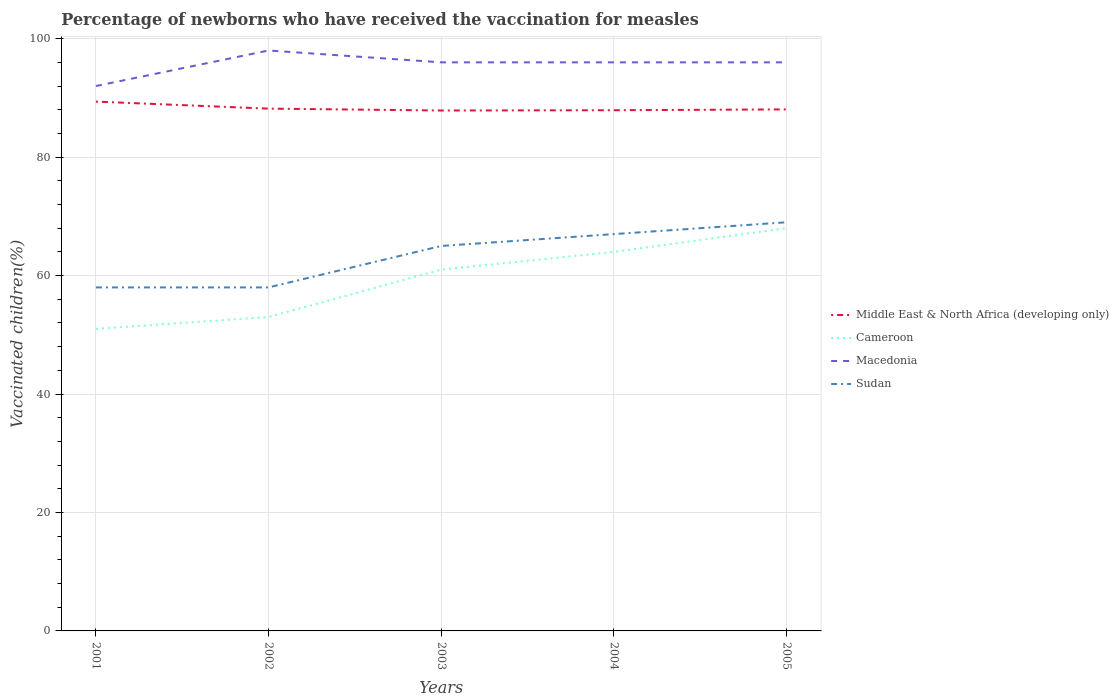How many different coloured lines are there?
Your answer should be very brief. 4. Is the number of lines equal to the number of legend labels?
Offer a very short reply. Yes. Across all years, what is the maximum percentage of vaccinated children in Middle East & North Africa (developing only)?
Provide a succinct answer. 87.87. In which year was the percentage of vaccinated children in Sudan maximum?
Offer a very short reply. 2001. How many lines are there?
Your response must be concise. 4. How many years are there in the graph?
Give a very brief answer. 5. Are the values on the major ticks of Y-axis written in scientific E-notation?
Keep it short and to the point. No. Does the graph contain any zero values?
Make the answer very short. No. What is the title of the graph?
Your answer should be very brief. Percentage of newborns who have received the vaccination for measles. What is the label or title of the Y-axis?
Your answer should be compact. Vaccinated children(%). What is the Vaccinated children(%) of Middle East & North Africa (developing only) in 2001?
Keep it short and to the point. 89.37. What is the Vaccinated children(%) in Macedonia in 2001?
Offer a very short reply. 92. What is the Vaccinated children(%) of Middle East & North Africa (developing only) in 2002?
Offer a very short reply. 88.19. What is the Vaccinated children(%) in Macedonia in 2002?
Your response must be concise. 98. What is the Vaccinated children(%) of Sudan in 2002?
Offer a terse response. 58. What is the Vaccinated children(%) of Middle East & North Africa (developing only) in 2003?
Give a very brief answer. 87.87. What is the Vaccinated children(%) in Cameroon in 2003?
Offer a terse response. 61. What is the Vaccinated children(%) of Macedonia in 2003?
Offer a terse response. 96. What is the Vaccinated children(%) in Sudan in 2003?
Offer a very short reply. 65. What is the Vaccinated children(%) of Middle East & North Africa (developing only) in 2004?
Ensure brevity in your answer.  87.91. What is the Vaccinated children(%) of Cameroon in 2004?
Keep it short and to the point. 64. What is the Vaccinated children(%) of Macedonia in 2004?
Provide a succinct answer. 96. What is the Vaccinated children(%) of Middle East & North Africa (developing only) in 2005?
Your response must be concise. 88.05. What is the Vaccinated children(%) in Macedonia in 2005?
Your answer should be very brief. 96. Across all years, what is the maximum Vaccinated children(%) of Middle East & North Africa (developing only)?
Provide a short and direct response. 89.37. Across all years, what is the maximum Vaccinated children(%) in Sudan?
Offer a very short reply. 69. Across all years, what is the minimum Vaccinated children(%) in Middle East & North Africa (developing only)?
Give a very brief answer. 87.87. Across all years, what is the minimum Vaccinated children(%) in Macedonia?
Ensure brevity in your answer.  92. What is the total Vaccinated children(%) in Middle East & North Africa (developing only) in the graph?
Give a very brief answer. 441.39. What is the total Vaccinated children(%) in Cameroon in the graph?
Ensure brevity in your answer.  297. What is the total Vaccinated children(%) in Macedonia in the graph?
Provide a short and direct response. 478. What is the total Vaccinated children(%) in Sudan in the graph?
Give a very brief answer. 317. What is the difference between the Vaccinated children(%) of Middle East & North Africa (developing only) in 2001 and that in 2002?
Offer a very short reply. 1.19. What is the difference between the Vaccinated children(%) in Cameroon in 2001 and that in 2002?
Your answer should be very brief. -2. What is the difference between the Vaccinated children(%) of Sudan in 2001 and that in 2002?
Offer a terse response. 0. What is the difference between the Vaccinated children(%) of Middle East & North Africa (developing only) in 2001 and that in 2003?
Give a very brief answer. 1.51. What is the difference between the Vaccinated children(%) of Sudan in 2001 and that in 2003?
Provide a short and direct response. -7. What is the difference between the Vaccinated children(%) in Middle East & North Africa (developing only) in 2001 and that in 2004?
Give a very brief answer. 1.46. What is the difference between the Vaccinated children(%) in Cameroon in 2001 and that in 2004?
Offer a terse response. -13. What is the difference between the Vaccinated children(%) in Macedonia in 2001 and that in 2004?
Offer a very short reply. -4. What is the difference between the Vaccinated children(%) in Sudan in 2001 and that in 2004?
Your response must be concise. -9. What is the difference between the Vaccinated children(%) in Middle East & North Africa (developing only) in 2001 and that in 2005?
Provide a short and direct response. 1.32. What is the difference between the Vaccinated children(%) of Cameroon in 2001 and that in 2005?
Your answer should be compact. -17. What is the difference between the Vaccinated children(%) of Macedonia in 2001 and that in 2005?
Offer a very short reply. -4. What is the difference between the Vaccinated children(%) in Sudan in 2001 and that in 2005?
Your response must be concise. -11. What is the difference between the Vaccinated children(%) of Middle East & North Africa (developing only) in 2002 and that in 2003?
Ensure brevity in your answer.  0.32. What is the difference between the Vaccinated children(%) in Macedonia in 2002 and that in 2003?
Your answer should be very brief. 2. What is the difference between the Vaccinated children(%) in Middle East & North Africa (developing only) in 2002 and that in 2004?
Provide a short and direct response. 0.27. What is the difference between the Vaccinated children(%) of Cameroon in 2002 and that in 2004?
Your answer should be very brief. -11. What is the difference between the Vaccinated children(%) in Macedonia in 2002 and that in 2004?
Offer a terse response. 2. What is the difference between the Vaccinated children(%) of Middle East & North Africa (developing only) in 2002 and that in 2005?
Your answer should be compact. 0.13. What is the difference between the Vaccinated children(%) of Sudan in 2002 and that in 2005?
Offer a very short reply. -11. What is the difference between the Vaccinated children(%) in Middle East & North Africa (developing only) in 2003 and that in 2004?
Offer a terse response. -0.05. What is the difference between the Vaccinated children(%) in Macedonia in 2003 and that in 2004?
Your answer should be compact. 0. What is the difference between the Vaccinated children(%) in Sudan in 2003 and that in 2004?
Offer a terse response. -2. What is the difference between the Vaccinated children(%) in Middle East & North Africa (developing only) in 2003 and that in 2005?
Your answer should be compact. -0.19. What is the difference between the Vaccinated children(%) of Cameroon in 2003 and that in 2005?
Your answer should be very brief. -7. What is the difference between the Vaccinated children(%) in Macedonia in 2003 and that in 2005?
Your response must be concise. 0. What is the difference between the Vaccinated children(%) of Middle East & North Africa (developing only) in 2004 and that in 2005?
Give a very brief answer. -0.14. What is the difference between the Vaccinated children(%) in Cameroon in 2004 and that in 2005?
Offer a terse response. -4. What is the difference between the Vaccinated children(%) of Macedonia in 2004 and that in 2005?
Your answer should be compact. 0. What is the difference between the Vaccinated children(%) of Middle East & North Africa (developing only) in 2001 and the Vaccinated children(%) of Cameroon in 2002?
Ensure brevity in your answer.  36.37. What is the difference between the Vaccinated children(%) of Middle East & North Africa (developing only) in 2001 and the Vaccinated children(%) of Macedonia in 2002?
Offer a terse response. -8.63. What is the difference between the Vaccinated children(%) in Middle East & North Africa (developing only) in 2001 and the Vaccinated children(%) in Sudan in 2002?
Make the answer very short. 31.37. What is the difference between the Vaccinated children(%) of Cameroon in 2001 and the Vaccinated children(%) of Macedonia in 2002?
Ensure brevity in your answer.  -47. What is the difference between the Vaccinated children(%) in Macedonia in 2001 and the Vaccinated children(%) in Sudan in 2002?
Offer a terse response. 34. What is the difference between the Vaccinated children(%) in Middle East & North Africa (developing only) in 2001 and the Vaccinated children(%) in Cameroon in 2003?
Make the answer very short. 28.37. What is the difference between the Vaccinated children(%) in Middle East & North Africa (developing only) in 2001 and the Vaccinated children(%) in Macedonia in 2003?
Your answer should be compact. -6.63. What is the difference between the Vaccinated children(%) of Middle East & North Africa (developing only) in 2001 and the Vaccinated children(%) of Sudan in 2003?
Your response must be concise. 24.37. What is the difference between the Vaccinated children(%) of Cameroon in 2001 and the Vaccinated children(%) of Macedonia in 2003?
Provide a short and direct response. -45. What is the difference between the Vaccinated children(%) in Macedonia in 2001 and the Vaccinated children(%) in Sudan in 2003?
Your answer should be compact. 27. What is the difference between the Vaccinated children(%) of Middle East & North Africa (developing only) in 2001 and the Vaccinated children(%) of Cameroon in 2004?
Offer a very short reply. 25.37. What is the difference between the Vaccinated children(%) in Middle East & North Africa (developing only) in 2001 and the Vaccinated children(%) in Macedonia in 2004?
Give a very brief answer. -6.63. What is the difference between the Vaccinated children(%) of Middle East & North Africa (developing only) in 2001 and the Vaccinated children(%) of Sudan in 2004?
Offer a very short reply. 22.37. What is the difference between the Vaccinated children(%) in Cameroon in 2001 and the Vaccinated children(%) in Macedonia in 2004?
Give a very brief answer. -45. What is the difference between the Vaccinated children(%) of Macedonia in 2001 and the Vaccinated children(%) of Sudan in 2004?
Your answer should be very brief. 25. What is the difference between the Vaccinated children(%) of Middle East & North Africa (developing only) in 2001 and the Vaccinated children(%) of Cameroon in 2005?
Keep it short and to the point. 21.37. What is the difference between the Vaccinated children(%) of Middle East & North Africa (developing only) in 2001 and the Vaccinated children(%) of Macedonia in 2005?
Keep it short and to the point. -6.63. What is the difference between the Vaccinated children(%) of Middle East & North Africa (developing only) in 2001 and the Vaccinated children(%) of Sudan in 2005?
Provide a succinct answer. 20.37. What is the difference between the Vaccinated children(%) in Cameroon in 2001 and the Vaccinated children(%) in Macedonia in 2005?
Your answer should be very brief. -45. What is the difference between the Vaccinated children(%) in Middle East & North Africa (developing only) in 2002 and the Vaccinated children(%) in Cameroon in 2003?
Your response must be concise. 27.19. What is the difference between the Vaccinated children(%) of Middle East & North Africa (developing only) in 2002 and the Vaccinated children(%) of Macedonia in 2003?
Make the answer very short. -7.81. What is the difference between the Vaccinated children(%) in Middle East & North Africa (developing only) in 2002 and the Vaccinated children(%) in Sudan in 2003?
Offer a terse response. 23.19. What is the difference between the Vaccinated children(%) in Cameroon in 2002 and the Vaccinated children(%) in Macedonia in 2003?
Provide a succinct answer. -43. What is the difference between the Vaccinated children(%) in Cameroon in 2002 and the Vaccinated children(%) in Sudan in 2003?
Offer a terse response. -12. What is the difference between the Vaccinated children(%) in Middle East & North Africa (developing only) in 2002 and the Vaccinated children(%) in Cameroon in 2004?
Offer a terse response. 24.19. What is the difference between the Vaccinated children(%) in Middle East & North Africa (developing only) in 2002 and the Vaccinated children(%) in Macedonia in 2004?
Make the answer very short. -7.81. What is the difference between the Vaccinated children(%) of Middle East & North Africa (developing only) in 2002 and the Vaccinated children(%) of Sudan in 2004?
Offer a terse response. 21.19. What is the difference between the Vaccinated children(%) of Cameroon in 2002 and the Vaccinated children(%) of Macedonia in 2004?
Give a very brief answer. -43. What is the difference between the Vaccinated children(%) of Cameroon in 2002 and the Vaccinated children(%) of Sudan in 2004?
Offer a very short reply. -14. What is the difference between the Vaccinated children(%) in Middle East & North Africa (developing only) in 2002 and the Vaccinated children(%) in Cameroon in 2005?
Your response must be concise. 20.19. What is the difference between the Vaccinated children(%) in Middle East & North Africa (developing only) in 2002 and the Vaccinated children(%) in Macedonia in 2005?
Make the answer very short. -7.81. What is the difference between the Vaccinated children(%) of Middle East & North Africa (developing only) in 2002 and the Vaccinated children(%) of Sudan in 2005?
Ensure brevity in your answer.  19.19. What is the difference between the Vaccinated children(%) in Cameroon in 2002 and the Vaccinated children(%) in Macedonia in 2005?
Make the answer very short. -43. What is the difference between the Vaccinated children(%) in Cameroon in 2002 and the Vaccinated children(%) in Sudan in 2005?
Offer a very short reply. -16. What is the difference between the Vaccinated children(%) of Middle East & North Africa (developing only) in 2003 and the Vaccinated children(%) of Cameroon in 2004?
Provide a succinct answer. 23.87. What is the difference between the Vaccinated children(%) in Middle East & North Africa (developing only) in 2003 and the Vaccinated children(%) in Macedonia in 2004?
Offer a terse response. -8.13. What is the difference between the Vaccinated children(%) of Middle East & North Africa (developing only) in 2003 and the Vaccinated children(%) of Sudan in 2004?
Your response must be concise. 20.87. What is the difference between the Vaccinated children(%) in Cameroon in 2003 and the Vaccinated children(%) in Macedonia in 2004?
Your response must be concise. -35. What is the difference between the Vaccinated children(%) of Middle East & North Africa (developing only) in 2003 and the Vaccinated children(%) of Cameroon in 2005?
Keep it short and to the point. 19.87. What is the difference between the Vaccinated children(%) of Middle East & North Africa (developing only) in 2003 and the Vaccinated children(%) of Macedonia in 2005?
Offer a terse response. -8.13. What is the difference between the Vaccinated children(%) of Middle East & North Africa (developing only) in 2003 and the Vaccinated children(%) of Sudan in 2005?
Provide a succinct answer. 18.87. What is the difference between the Vaccinated children(%) in Cameroon in 2003 and the Vaccinated children(%) in Macedonia in 2005?
Keep it short and to the point. -35. What is the difference between the Vaccinated children(%) of Cameroon in 2003 and the Vaccinated children(%) of Sudan in 2005?
Ensure brevity in your answer.  -8. What is the difference between the Vaccinated children(%) in Macedonia in 2003 and the Vaccinated children(%) in Sudan in 2005?
Offer a very short reply. 27. What is the difference between the Vaccinated children(%) of Middle East & North Africa (developing only) in 2004 and the Vaccinated children(%) of Cameroon in 2005?
Make the answer very short. 19.91. What is the difference between the Vaccinated children(%) in Middle East & North Africa (developing only) in 2004 and the Vaccinated children(%) in Macedonia in 2005?
Your response must be concise. -8.09. What is the difference between the Vaccinated children(%) of Middle East & North Africa (developing only) in 2004 and the Vaccinated children(%) of Sudan in 2005?
Ensure brevity in your answer.  18.91. What is the difference between the Vaccinated children(%) in Cameroon in 2004 and the Vaccinated children(%) in Macedonia in 2005?
Your answer should be very brief. -32. What is the difference between the Vaccinated children(%) of Cameroon in 2004 and the Vaccinated children(%) of Sudan in 2005?
Offer a terse response. -5. What is the difference between the Vaccinated children(%) of Macedonia in 2004 and the Vaccinated children(%) of Sudan in 2005?
Offer a terse response. 27. What is the average Vaccinated children(%) in Middle East & North Africa (developing only) per year?
Offer a terse response. 88.28. What is the average Vaccinated children(%) of Cameroon per year?
Ensure brevity in your answer.  59.4. What is the average Vaccinated children(%) in Macedonia per year?
Provide a short and direct response. 95.6. What is the average Vaccinated children(%) of Sudan per year?
Your answer should be compact. 63.4. In the year 2001, what is the difference between the Vaccinated children(%) of Middle East & North Africa (developing only) and Vaccinated children(%) of Cameroon?
Keep it short and to the point. 38.37. In the year 2001, what is the difference between the Vaccinated children(%) of Middle East & North Africa (developing only) and Vaccinated children(%) of Macedonia?
Give a very brief answer. -2.63. In the year 2001, what is the difference between the Vaccinated children(%) in Middle East & North Africa (developing only) and Vaccinated children(%) in Sudan?
Offer a very short reply. 31.37. In the year 2001, what is the difference between the Vaccinated children(%) in Cameroon and Vaccinated children(%) in Macedonia?
Offer a very short reply. -41. In the year 2001, what is the difference between the Vaccinated children(%) in Macedonia and Vaccinated children(%) in Sudan?
Offer a very short reply. 34. In the year 2002, what is the difference between the Vaccinated children(%) of Middle East & North Africa (developing only) and Vaccinated children(%) of Cameroon?
Your response must be concise. 35.19. In the year 2002, what is the difference between the Vaccinated children(%) of Middle East & North Africa (developing only) and Vaccinated children(%) of Macedonia?
Offer a terse response. -9.81. In the year 2002, what is the difference between the Vaccinated children(%) of Middle East & North Africa (developing only) and Vaccinated children(%) of Sudan?
Provide a succinct answer. 30.19. In the year 2002, what is the difference between the Vaccinated children(%) of Cameroon and Vaccinated children(%) of Macedonia?
Ensure brevity in your answer.  -45. In the year 2003, what is the difference between the Vaccinated children(%) in Middle East & North Africa (developing only) and Vaccinated children(%) in Cameroon?
Provide a short and direct response. 26.87. In the year 2003, what is the difference between the Vaccinated children(%) of Middle East & North Africa (developing only) and Vaccinated children(%) of Macedonia?
Your response must be concise. -8.13. In the year 2003, what is the difference between the Vaccinated children(%) of Middle East & North Africa (developing only) and Vaccinated children(%) of Sudan?
Offer a very short reply. 22.87. In the year 2003, what is the difference between the Vaccinated children(%) of Cameroon and Vaccinated children(%) of Macedonia?
Your answer should be compact. -35. In the year 2003, what is the difference between the Vaccinated children(%) in Cameroon and Vaccinated children(%) in Sudan?
Make the answer very short. -4. In the year 2004, what is the difference between the Vaccinated children(%) in Middle East & North Africa (developing only) and Vaccinated children(%) in Cameroon?
Provide a succinct answer. 23.91. In the year 2004, what is the difference between the Vaccinated children(%) in Middle East & North Africa (developing only) and Vaccinated children(%) in Macedonia?
Offer a very short reply. -8.09. In the year 2004, what is the difference between the Vaccinated children(%) of Middle East & North Africa (developing only) and Vaccinated children(%) of Sudan?
Keep it short and to the point. 20.91. In the year 2004, what is the difference between the Vaccinated children(%) in Cameroon and Vaccinated children(%) in Macedonia?
Ensure brevity in your answer.  -32. In the year 2005, what is the difference between the Vaccinated children(%) of Middle East & North Africa (developing only) and Vaccinated children(%) of Cameroon?
Your answer should be compact. 20.05. In the year 2005, what is the difference between the Vaccinated children(%) of Middle East & North Africa (developing only) and Vaccinated children(%) of Macedonia?
Offer a very short reply. -7.95. In the year 2005, what is the difference between the Vaccinated children(%) in Middle East & North Africa (developing only) and Vaccinated children(%) in Sudan?
Your answer should be compact. 19.05. In the year 2005, what is the difference between the Vaccinated children(%) in Cameroon and Vaccinated children(%) in Macedonia?
Keep it short and to the point. -28. In the year 2005, what is the difference between the Vaccinated children(%) of Cameroon and Vaccinated children(%) of Sudan?
Your answer should be very brief. -1. What is the ratio of the Vaccinated children(%) in Middle East & North Africa (developing only) in 2001 to that in 2002?
Offer a terse response. 1.01. What is the ratio of the Vaccinated children(%) in Cameroon in 2001 to that in 2002?
Give a very brief answer. 0.96. What is the ratio of the Vaccinated children(%) of Macedonia in 2001 to that in 2002?
Give a very brief answer. 0.94. What is the ratio of the Vaccinated children(%) of Middle East & North Africa (developing only) in 2001 to that in 2003?
Your answer should be very brief. 1.02. What is the ratio of the Vaccinated children(%) of Cameroon in 2001 to that in 2003?
Ensure brevity in your answer.  0.84. What is the ratio of the Vaccinated children(%) in Macedonia in 2001 to that in 2003?
Provide a succinct answer. 0.96. What is the ratio of the Vaccinated children(%) of Sudan in 2001 to that in 2003?
Make the answer very short. 0.89. What is the ratio of the Vaccinated children(%) in Middle East & North Africa (developing only) in 2001 to that in 2004?
Ensure brevity in your answer.  1.02. What is the ratio of the Vaccinated children(%) of Cameroon in 2001 to that in 2004?
Your response must be concise. 0.8. What is the ratio of the Vaccinated children(%) in Sudan in 2001 to that in 2004?
Offer a terse response. 0.87. What is the ratio of the Vaccinated children(%) in Cameroon in 2001 to that in 2005?
Your answer should be very brief. 0.75. What is the ratio of the Vaccinated children(%) of Macedonia in 2001 to that in 2005?
Your answer should be compact. 0.96. What is the ratio of the Vaccinated children(%) in Sudan in 2001 to that in 2005?
Ensure brevity in your answer.  0.84. What is the ratio of the Vaccinated children(%) in Cameroon in 2002 to that in 2003?
Keep it short and to the point. 0.87. What is the ratio of the Vaccinated children(%) of Macedonia in 2002 to that in 2003?
Your answer should be compact. 1.02. What is the ratio of the Vaccinated children(%) in Sudan in 2002 to that in 2003?
Give a very brief answer. 0.89. What is the ratio of the Vaccinated children(%) in Cameroon in 2002 to that in 2004?
Your response must be concise. 0.83. What is the ratio of the Vaccinated children(%) of Macedonia in 2002 to that in 2004?
Provide a succinct answer. 1.02. What is the ratio of the Vaccinated children(%) in Sudan in 2002 to that in 2004?
Your answer should be very brief. 0.87. What is the ratio of the Vaccinated children(%) of Middle East & North Africa (developing only) in 2002 to that in 2005?
Offer a very short reply. 1. What is the ratio of the Vaccinated children(%) in Cameroon in 2002 to that in 2005?
Give a very brief answer. 0.78. What is the ratio of the Vaccinated children(%) in Macedonia in 2002 to that in 2005?
Your answer should be compact. 1.02. What is the ratio of the Vaccinated children(%) in Sudan in 2002 to that in 2005?
Your answer should be compact. 0.84. What is the ratio of the Vaccinated children(%) of Cameroon in 2003 to that in 2004?
Offer a terse response. 0.95. What is the ratio of the Vaccinated children(%) in Macedonia in 2003 to that in 2004?
Offer a very short reply. 1. What is the ratio of the Vaccinated children(%) in Sudan in 2003 to that in 2004?
Offer a very short reply. 0.97. What is the ratio of the Vaccinated children(%) in Middle East & North Africa (developing only) in 2003 to that in 2005?
Provide a succinct answer. 1. What is the ratio of the Vaccinated children(%) in Cameroon in 2003 to that in 2005?
Give a very brief answer. 0.9. What is the ratio of the Vaccinated children(%) of Macedonia in 2003 to that in 2005?
Ensure brevity in your answer.  1. What is the ratio of the Vaccinated children(%) of Sudan in 2003 to that in 2005?
Give a very brief answer. 0.94. What is the ratio of the Vaccinated children(%) in Middle East & North Africa (developing only) in 2004 to that in 2005?
Offer a very short reply. 1. What is the difference between the highest and the second highest Vaccinated children(%) of Middle East & North Africa (developing only)?
Your answer should be compact. 1.19. What is the difference between the highest and the second highest Vaccinated children(%) in Macedonia?
Offer a very short reply. 2. What is the difference between the highest and the lowest Vaccinated children(%) in Middle East & North Africa (developing only)?
Provide a short and direct response. 1.51. What is the difference between the highest and the lowest Vaccinated children(%) in Macedonia?
Your answer should be compact. 6. What is the difference between the highest and the lowest Vaccinated children(%) of Sudan?
Your answer should be compact. 11. 